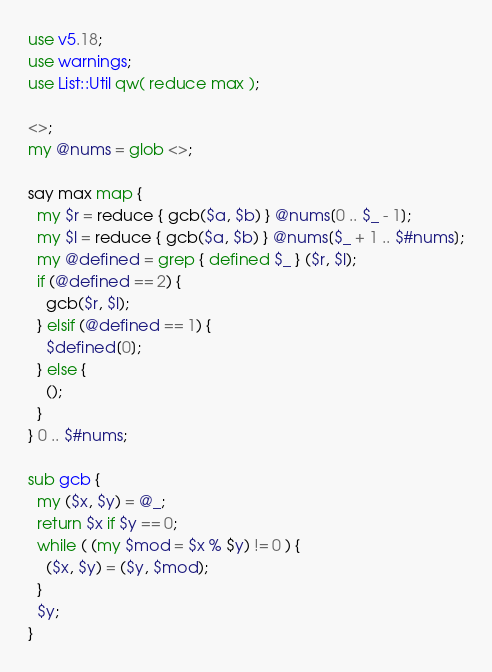<code> <loc_0><loc_0><loc_500><loc_500><_Perl_>use v5.18;
use warnings;
use List::Util qw( reduce max );

<>;
my @nums = glob <>;

say max map {
  my $r = reduce { gcb($a, $b) } @nums[0 .. $_ - 1];
  my $l = reduce { gcb($a, $b) } @nums[$_ + 1 .. $#nums];
  my @defined = grep { defined $_ } ($r, $l);
  if (@defined == 2) {
    gcb($r, $l);
  } elsif (@defined == 1) {
    $defined[0];
  } else {
    ();
  }
} 0 .. $#nums;

sub gcb {
  my ($x, $y) = @_;
  return $x if $y == 0;
  while ( (my $mod = $x % $y) != 0 ) {
    ($x, $y) = ($y, $mod);
  }
  $y;
}</code> 